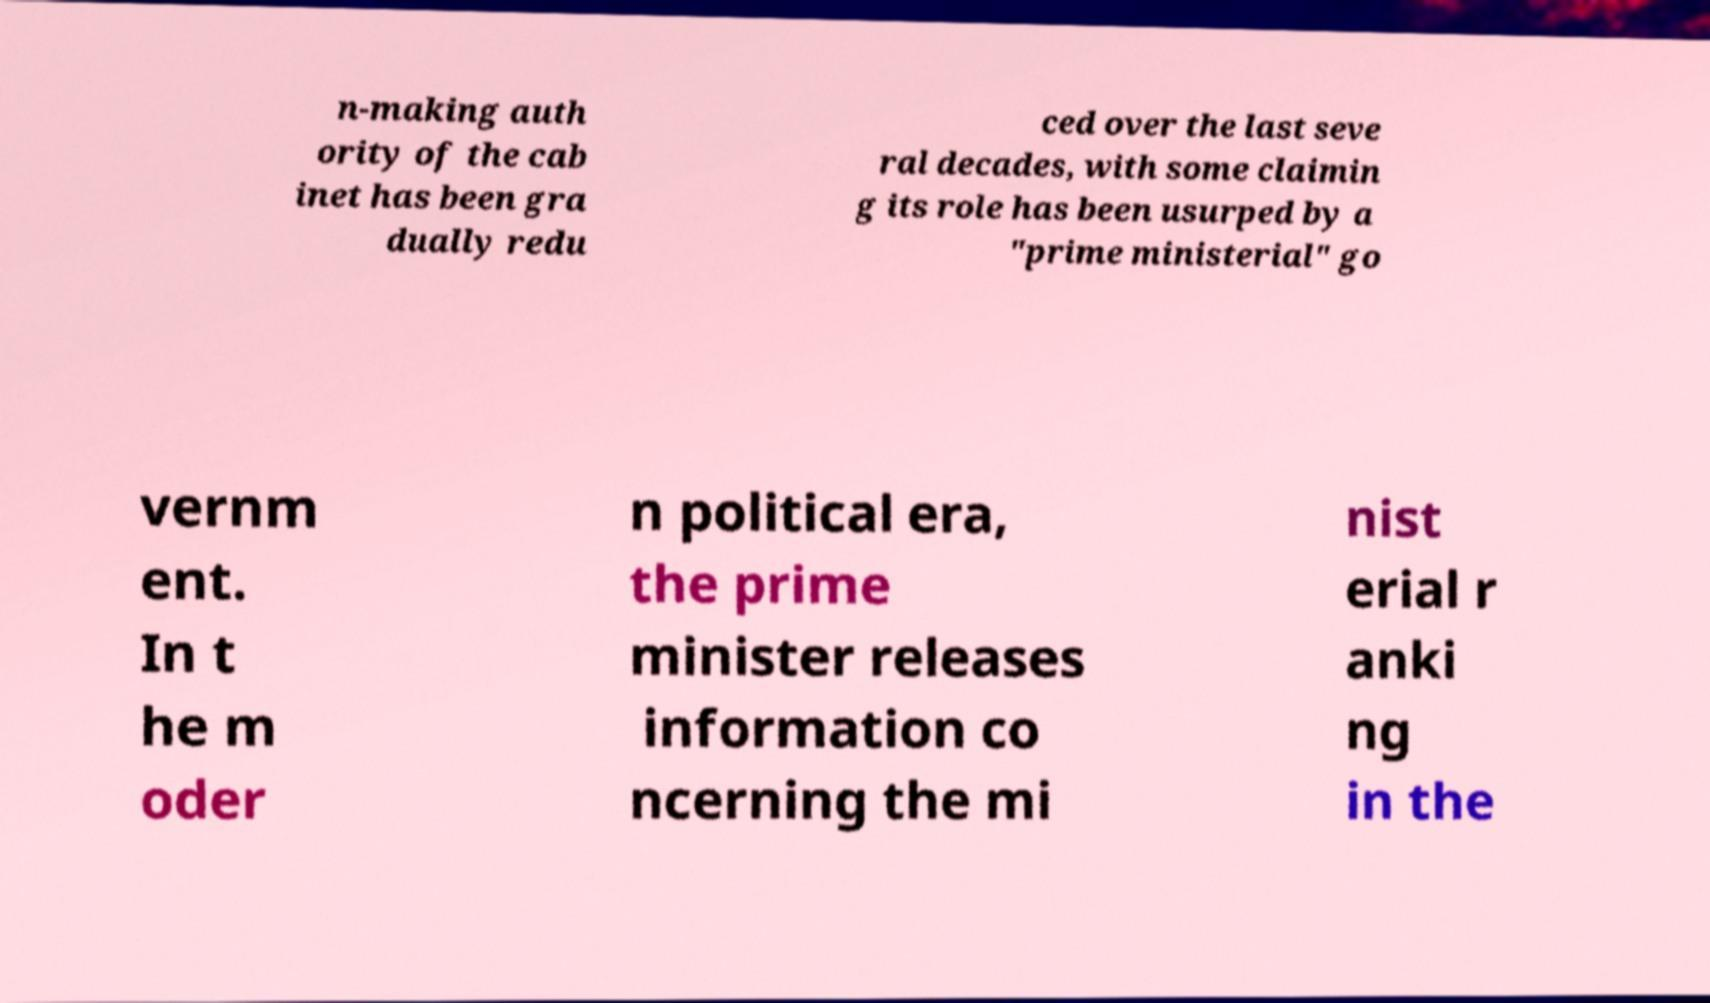Can you read and provide the text displayed in the image?This photo seems to have some interesting text. Can you extract and type it out for me? n-making auth ority of the cab inet has been gra dually redu ced over the last seve ral decades, with some claimin g its role has been usurped by a "prime ministerial" go vernm ent. In t he m oder n political era, the prime minister releases information co ncerning the mi nist erial r anki ng in the 